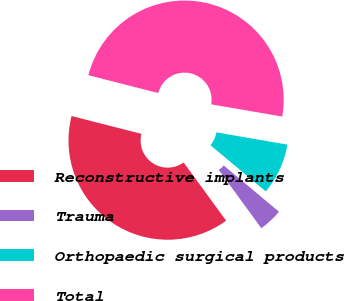Convert chart to OTSL. <chart><loc_0><loc_0><loc_500><loc_500><pie_chart><fcel>Reconstructive implants<fcel>Trauma<fcel>Orthopaedic surgical products<fcel>Total<nl><fcel>39.0%<fcel>3.89%<fcel>8.37%<fcel>48.74%<nl></chart> 